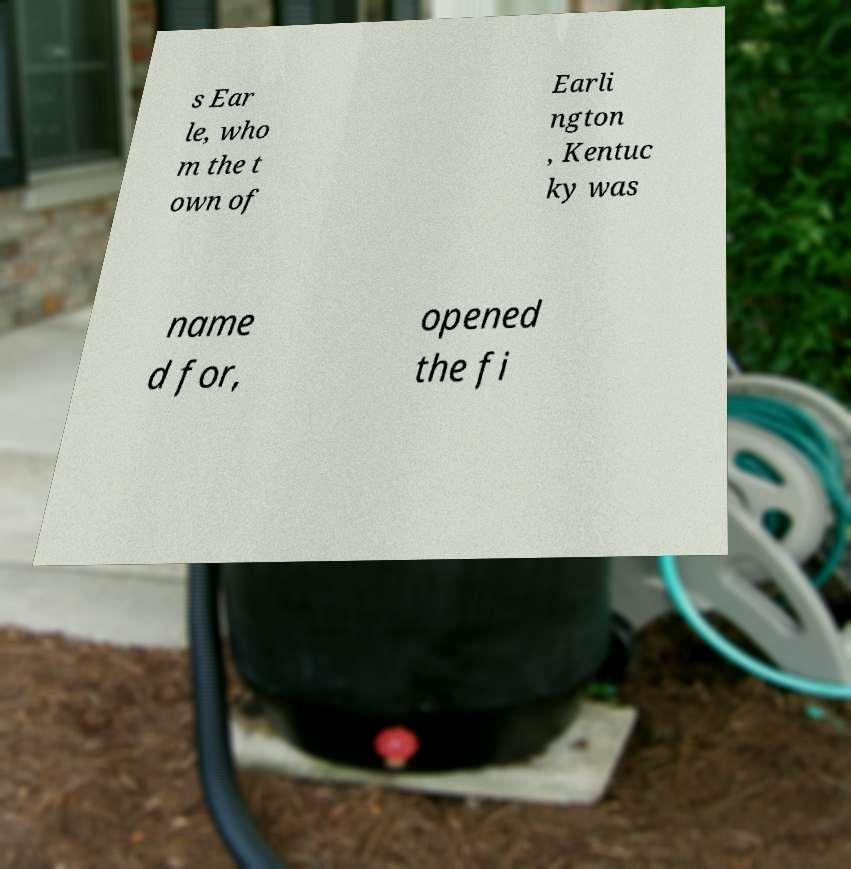Could you extract and type out the text from this image? s Ear le, who m the t own of Earli ngton , Kentuc ky was name d for, opened the fi 